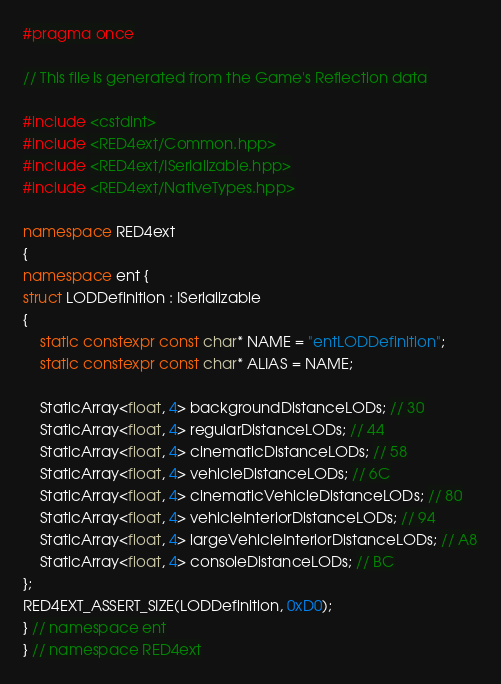Convert code to text. <code><loc_0><loc_0><loc_500><loc_500><_C++_>#pragma once

// This file is generated from the Game's Reflection data

#include <cstdint>
#include <RED4ext/Common.hpp>
#include <RED4ext/ISerializable.hpp>
#include <RED4ext/NativeTypes.hpp>

namespace RED4ext
{
namespace ent { 
struct LODDefinition : ISerializable
{
    static constexpr const char* NAME = "entLODDefinition";
    static constexpr const char* ALIAS = NAME;

    StaticArray<float, 4> backgroundDistanceLODs; // 30
    StaticArray<float, 4> regularDistanceLODs; // 44
    StaticArray<float, 4> cinematicDistanceLODs; // 58
    StaticArray<float, 4> vehicleDistanceLODs; // 6C
    StaticArray<float, 4> cinematicVehicleDistanceLODs; // 80
    StaticArray<float, 4> vehicleInteriorDistanceLODs; // 94
    StaticArray<float, 4> largeVehicleInteriorDistanceLODs; // A8
    StaticArray<float, 4> consoleDistanceLODs; // BC
};
RED4EXT_ASSERT_SIZE(LODDefinition, 0xD0);
} // namespace ent
} // namespace RED4ext
</code> 